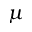Convert formula to latex. <formula><loc_0><loc_0><loc_500><loc_500>\mu</formula> 